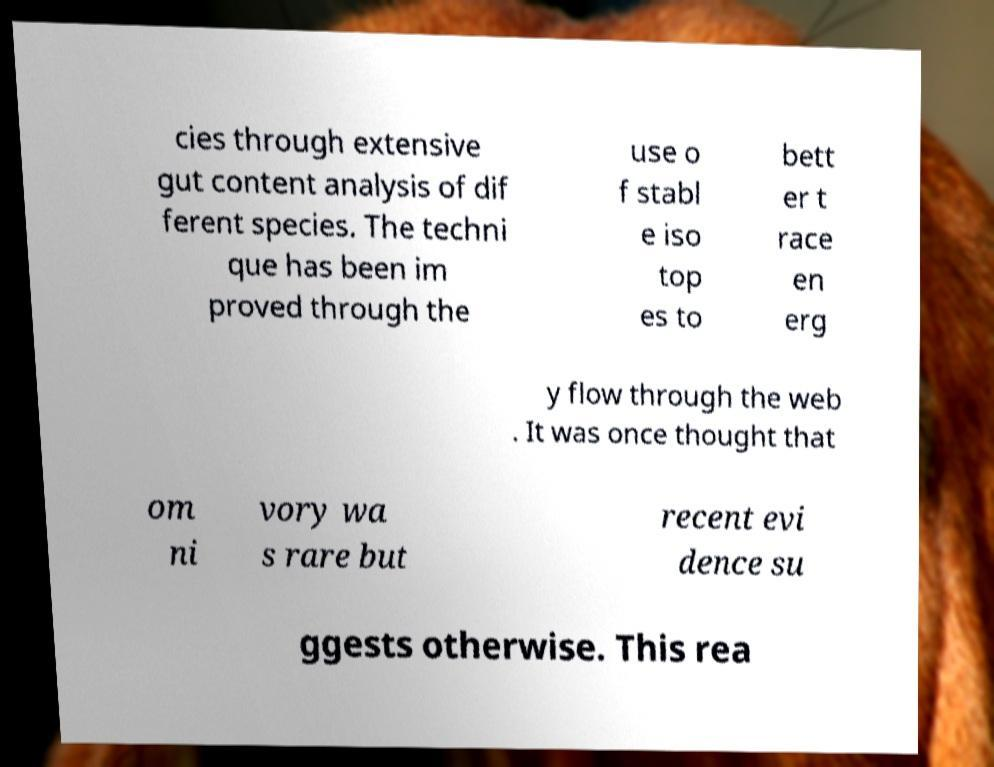Can you read and provide the text displayed in the image?This photo seems to have some interesting text. Can you extract and type it out for me? cies through extensive gut content analysis of dif ferent species. The techni que has been im proved through the use o f stabl e iso top es to bett er t race en erg y flow through the web . It was once thought that om ni vory wa s rare but recent evi dence su ggests otherwise. This rea 